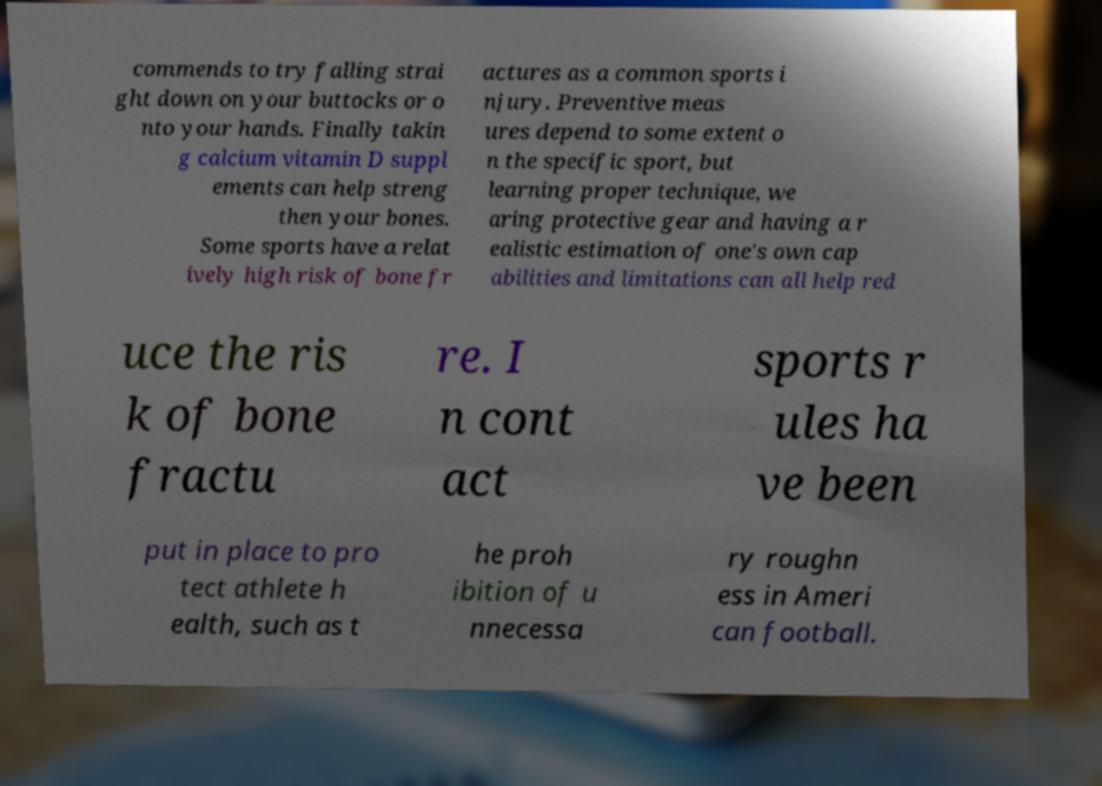Please identify and transcribe the text found in this image. commends to try falling strai ght down on your buttocks or o nto your hands. Finally takin g calcium vitamin D suppl ements can help streng then your bones. Some sports have a relat ively high risk of bone fr actures as a common sports i njury. Preventive meas ures depend to some extent o n the specific sport, but learning proper technique, we aring protective gear and having a r ealistic estimation of one's own cap abilities and limitations can all help red uce the ris k of bone fractu re. I n cont act sports r ules ha ve been put in place to pro tect athlete h ealth, such as t he proh ibition of u nnecessa ry roughn ess in Ameri can football. 